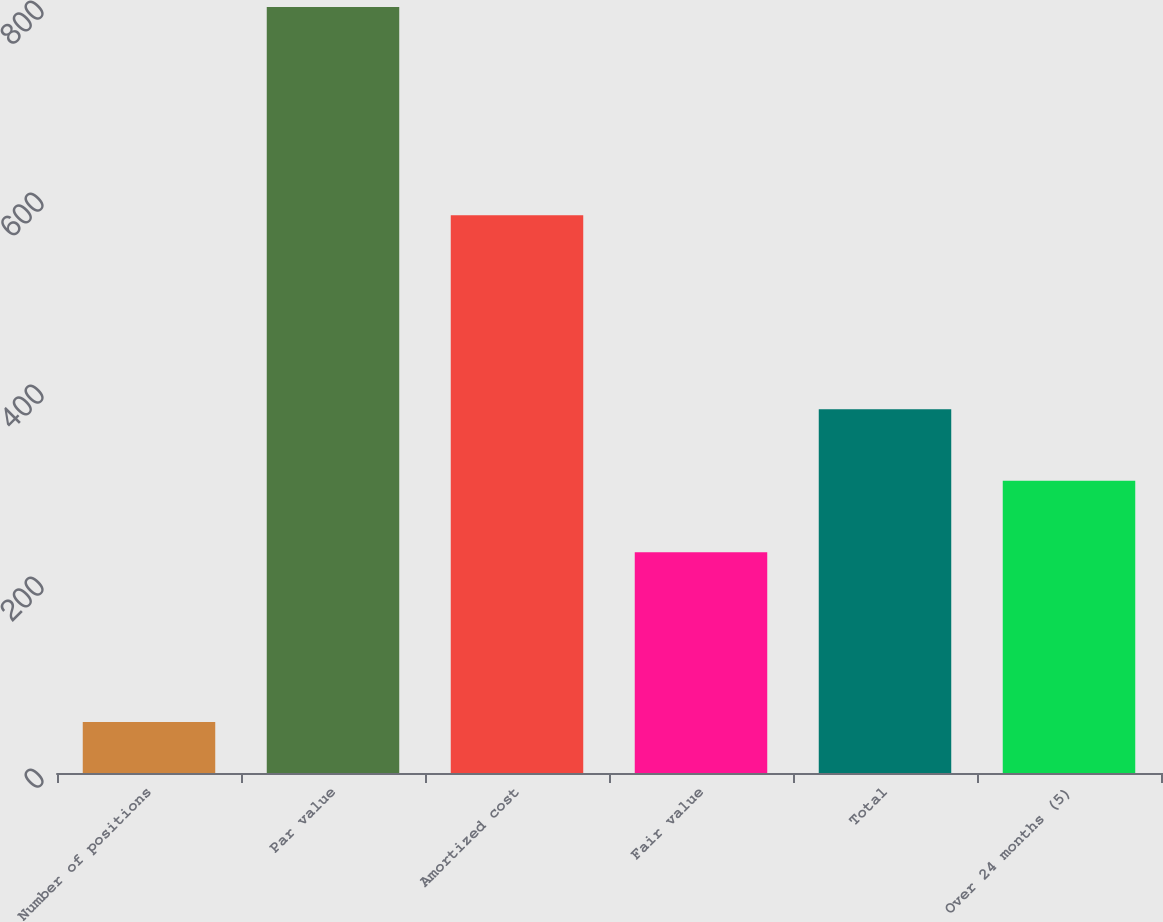Convert chart. <chart><loc_0><loc_0><loc_500><loc_500><bar_chart><fcel>Number of positions<fcel>Par value<fcel>Amortized cost<fcel>Fair value<fcel>Total<fcel>Over 24 months (5)<nl><fcel>53<fcel>798<fcel>581<fcel>230<fcel>379<fcel>304.5<nl></chart> 